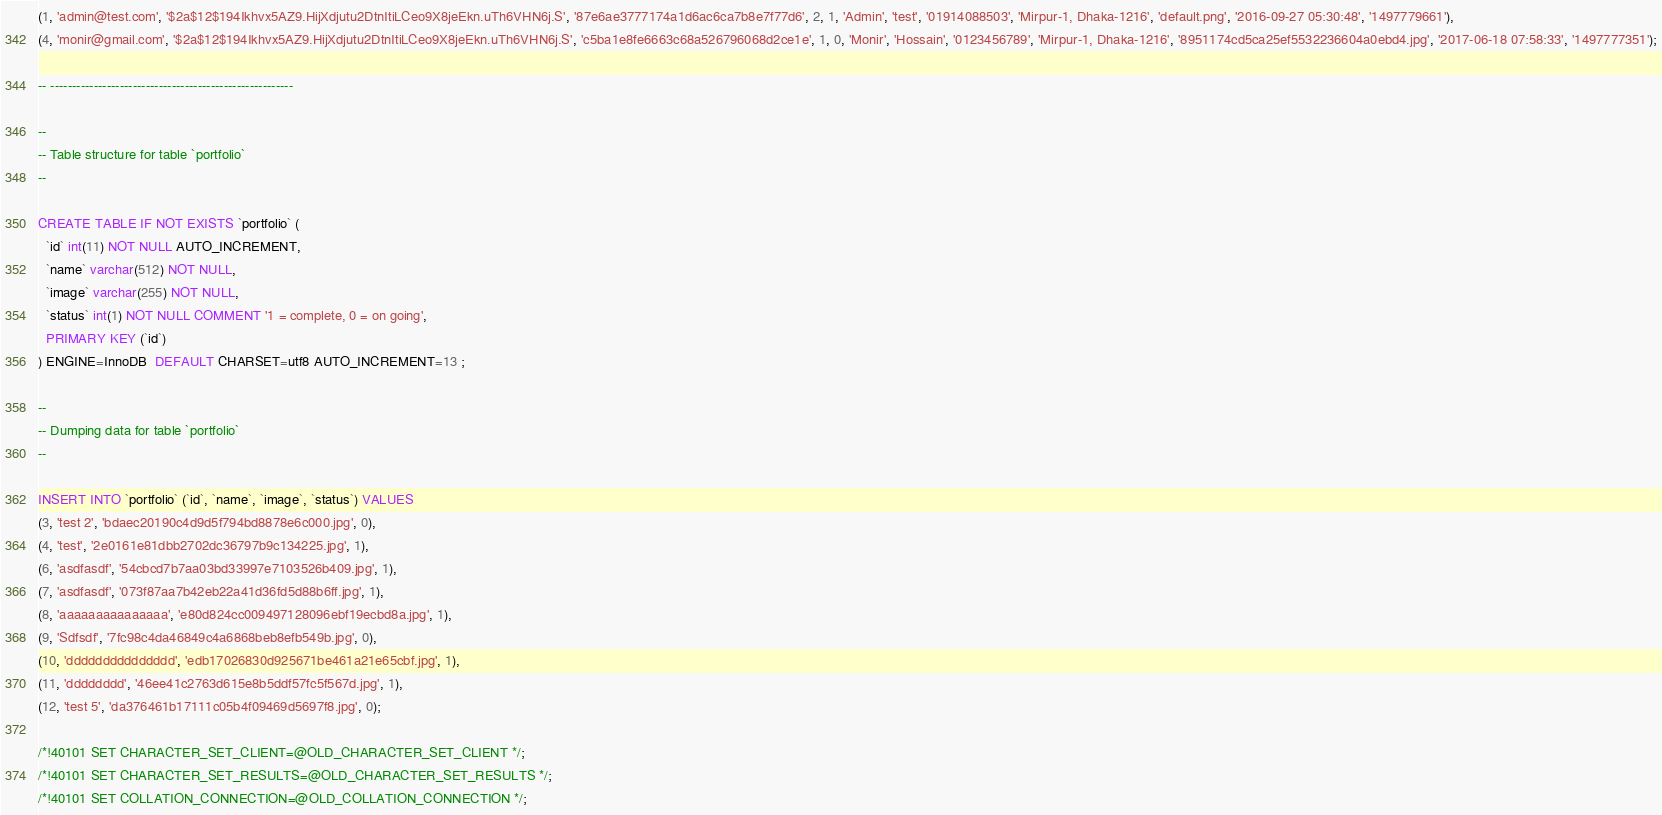<code> <loc_0><loc_0><loc_500><loc_500><_SQL_>(1, 'admin@test.com', '$2a$12$194Ikhvx5AZ9.HijXdjutu2DtnItiLCeo9X8jeEkn.uTh6VHN6j.S', '87e6ae3777174a1d6ac6ca7b8e7f77d6', 2, 1, 'Admin', 'test', '01914088503', 'Mirpur-1, Dhaka-1216', 'default.png', '2016-09-27 05:30:48', '1497779661'),
(4, 'monir@gmail.com', '$2a$12$194Ikhvx5AZ9.HijXdjutu2DtnItiLCeo9X8jeEkn.uTh6VHN6j.S', 'c5ba1e8fe6663c68a526796068d2ce1e', 1, 0, 'Monir', 'Hossain', '0123456789', 'Mirpur-1, Dhaka-1216', '8951174cd5ca25ef5532236604a0ebd4.jpg', '2017-06-18 07:58:33', '1497777351');

-- --------------------------------------------------------

--
-- Table structure for table `portfolio`
--

CREATE TABLE IF NOT EXISTS `portfolio` (
  `id` int(11) NOT NULL AUTO_INCREMENT,
  `name` varchar(512) NOT NULL,
  `image` varchar(255) NOT NULL,
  `status` int(1) NOT NULL COMMENT '1 = complete, 0 = on going',
  PRIMARY KEY (`id`)
) ENGINE=InnoDB  DEFAULT CHARSET=utf8 AUTO_INCREMENT=13 ;

--
-- Dumping data for table `portfolio`
--

INSERT INTO `portfolio` (`id`, `name`, `image`, `status`) VALUES
(3, 'test 2', 'bdaec20190c4d9d5f794bd8878e6c000.jpg', 0),
(4, 'test', '2e0161e81dbb2702dc36797b9c134225.jpg', 1),
(6, 'asdfasdf', '54cbcd7b7aa03bd33997e7103526b409.jpg', 1),
(7, 'asdfasdf', '073f87aa7b42eb22a41d36fd5d88b6ff.jpg', 1),
(8, 'aaaaaaaaaaaaaaa', 'e80d824cc009497128096ebf19ecbd8a.jpg', 1),
(9, 'Sdfsdf', '7fc98c4da46849c4a6868beb8efb549b.jpg', 0),
(10, 'ddddddddddddddd', 'edb17026830d925671be461a21e65cbf.jpg', 1),
(11, 'dddddddd', '46ee41c2763d615e8b5ddf57fc5f567d.jpg', 1),
(12, 'test 5', 'da376461b17111c05b4f09469d5697f8.jpg', 0);

/*!40101 SET CHARACTER_SET_CLIENT=@OLD_CHARACTER_SET_CLIENT */;
/*!40101 SET CHARACTER_SET_RESULTS=@OLD_CHARACTER_SET_RESULTS */;
/*!40101 SET COLLATION_CONNECTION=@OLD_COLLATION_CONNECTION */;
</code> 